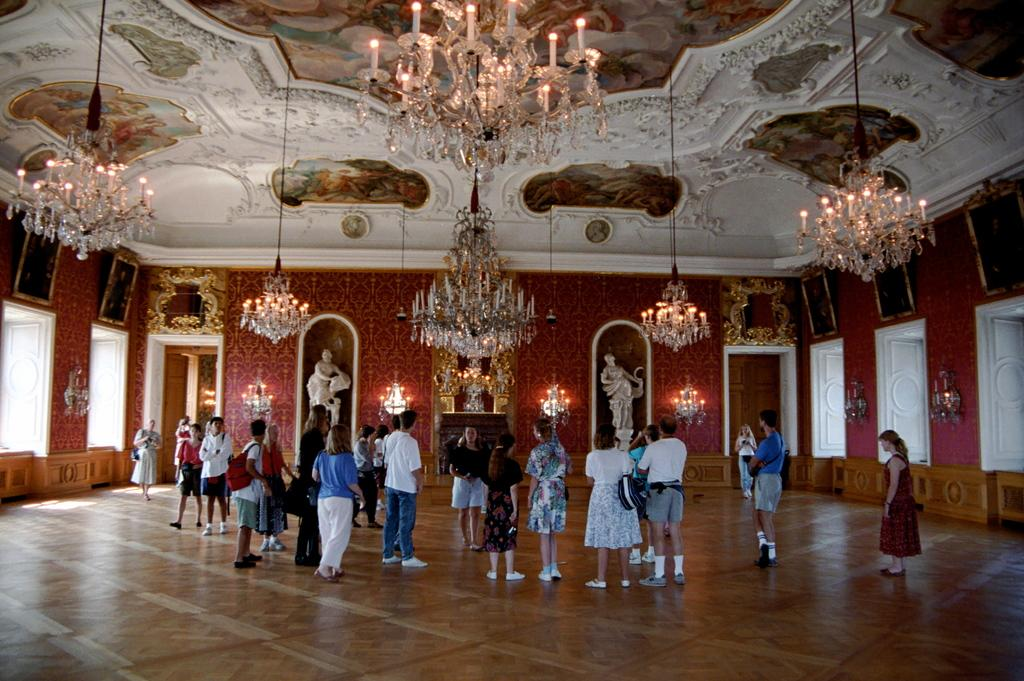Who or what is present in the image? There are people in the image. Where are the people located? The people are standing in a room. What type of lighting is present in the room? There are chandeliers in the room. What type of artwork can be seen in the room? There are paintings and sculptures in the room. What type of news can be heard from the shop in the image? There is no shop present in the image, and therefore no news can be heard. What flavor of jelly is being served in the room? There is no mention of jelly in the image, so it cannot be determined if any is being served. 